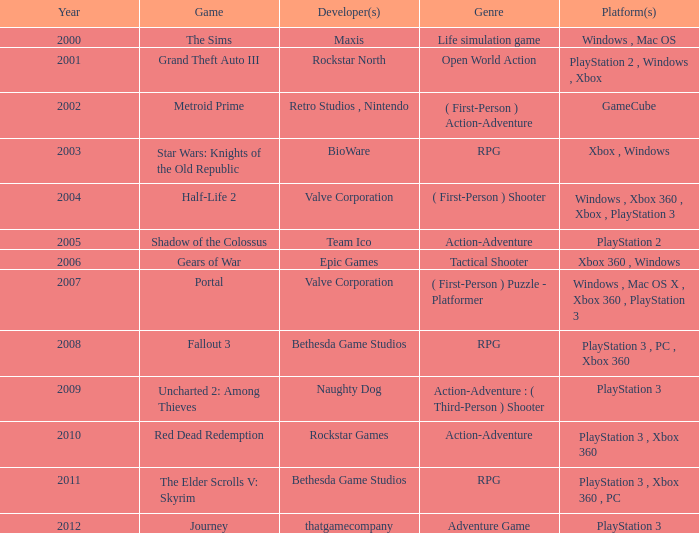In 2011, what game was launched? The Elder Scrolls V: Skyrim. 